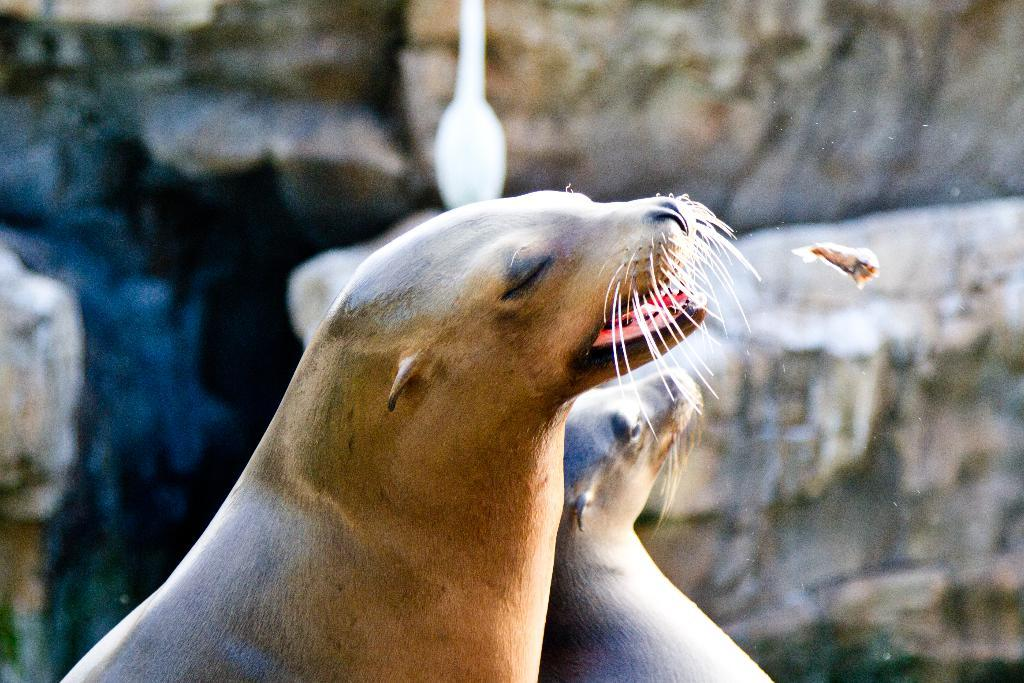What type of animals are in the image? There are seals in the image. What color are the seals? The seals are in brown color. What can be seen in the background of the image? There are rocks in the background of the image. How many books are stacked on the seat in the image? There are no books or seats present in the image; it features seals and rocks. 